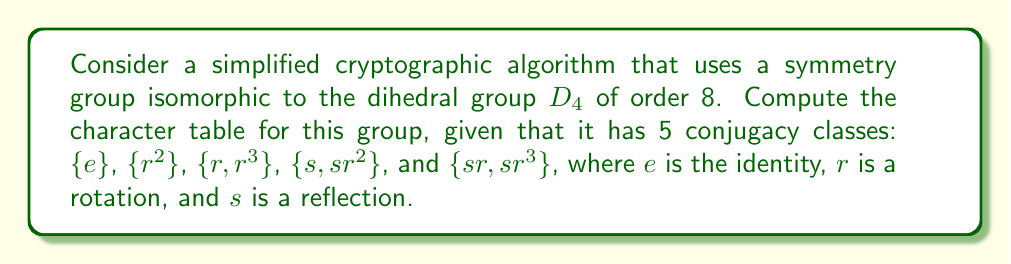Can you answer this question? To compute the character table for $D_4$, we'll follow these steps:

1) First, recall that the number of irreducible representations is equal to the number of conjugacy classes, which is 5 in this case.

2) We know that the sum of the squares of the dimensions of the irreducible representations must equal the order of the group (8). The only possibility is four 1-dimensional representations and one 2-dimensional representation.

3) Let's label the representations as $\chi_1, \chi_2, \chi_3, \chi_4$ (1-dimensional) and $\chi_5$ (2-dimensional).

4) $\chi_1$ is always the trivial representation, which assigns 1 to all elements.

5) For $\chi_2, \chi_3, \chi_4$, we can determine their values on $r$ and $s$:
   - $\chi_2(r) = 1, \chi_2(s) = -1$
   - $\chi_3(r) = -1, \chi_3(s) = 1$
   - $\chi_4(r) = -1, \chi_4(s) = -1$

6) For $\chi_5$, we can use the fact that the sum of squares of the entries in each column must equal 8:
   - $\chi_5(e) = 2$
   - $\chi_5(r^2) = -2$
   - $\chi_5(r) = \chi_5(r^3) = 0$
   - $\chi_5(s) = \chi_5(sr^2) = 0$
   - $\chi_5(sr) = \chi_5(sr^3) = 0$

7) We can now construct the character table:

$$
\begin{array}{c|ccccc}
D_4 & \{e\} & \{r^2\} & \{r, r^3\} & \{s, sr^2\} & \{sr, sr^3\} \\
\hline
\chi_1 & 1 & 1 & 1 & 1 & 1 \\
\chi_2 & 1 & 1 & 1 & -1 & -1 \\
\chi_3 & 1 & 1 & -1 & 1 & -1 \\
\chi_4 & 1 & 1 & -1 & -1 & 1 \\
\chi_5 & 2 & -2 & 0 & 0 & 0
\end{array}
$$

This character table represents the symmetries of the cryptographic algorithm, which could be useful in analyzing its properties and potential vulnerabilities.
Answer: $$
\begin{array}{c|ccccc}
D_4 & \{e\} & \{r^2\} & \{r, r^3\} & \{s, sr^2\} & \{sr, sr^3\} \\
\hline
\chi_1 & 1 & 1 & 1 & 1 & 1 \\
\chi_2 & 1 & 1 & 1 & -1 & -1 \\
\chi_3 & 1 & 1 & -1 & 1 & -1 \\
\chi_4 & 1 & 1 & -1 & -1 & 1 \\
\chi_5 & 2 & -2 & 0 & 0 & 0
\end{array}
$$ 